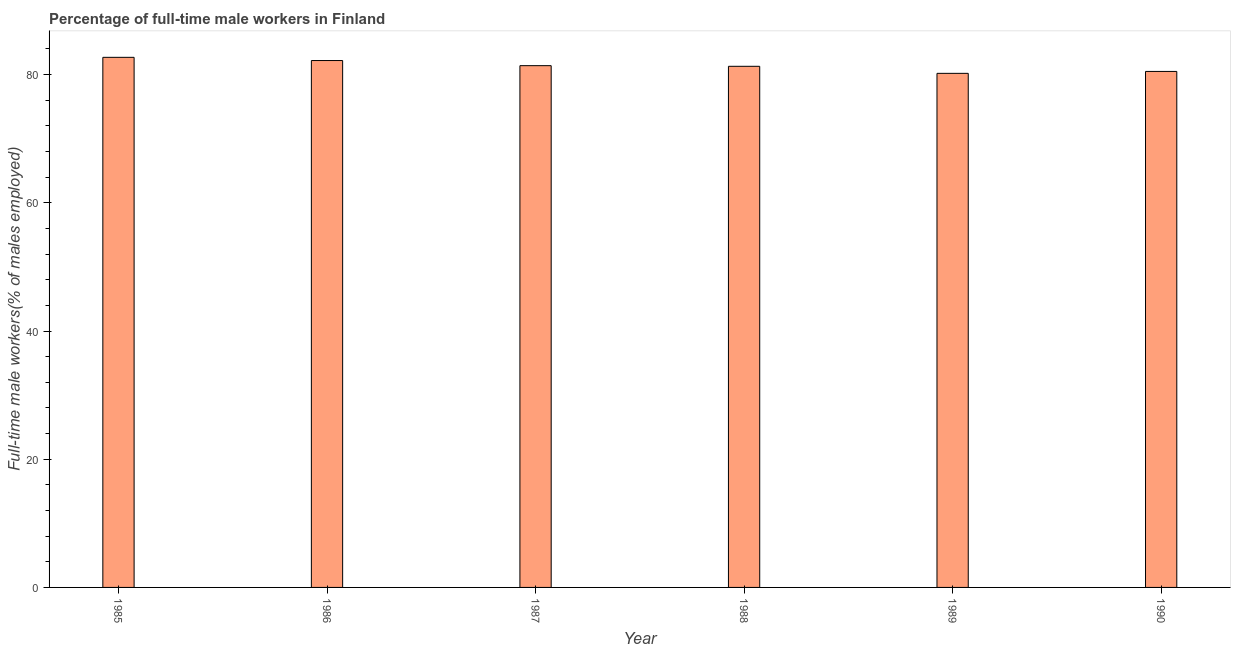Does the graph contain grids?
Your response must be concise. No. What is the title of the graph?
Provide a succinct answer. Percentage of full-time male workers in Finland. What is the label or title of the X-axis?
Make the answer very short. Year. What is the label or title of the Y-axis?
Offer a very short reply. Full-time male workers(% of males employed). What is the percentage of full-time male workers in 1987?
Your response must be concise. 81.4. Across all years, what is the maximum percentage of full-time male workers?
Offer a very short reply. 82.7. Across all years, what is the minimum percentage of full-time male workers?
Provide a short and direct response. 80.2. In which year was the percentage of full-time male workers maximum?
Give a very brief answer. 1985. What is the sum of the percentage of full-time male workers?
Keep it short and to the point. 488.3. What is the average percentage of full-time male workers per year?
Provide a short and direct response. 81.38. What is the median percentage of full-time male workers?
Your response must be concise. 81.35. What is the ratio of the percentage of full-time male workers in 1988 to that in 1990?
Provide a short and direct response. 1.01. Is the percentage of full-time male workers in 1986 less than that in 1989?
Provide a short and direct response. No. Is the difference between the percentage of full-time male workers in 1985 and 1986 greater than the difference between any two years?
Provide a short and direct response. No. What is the difference between the highest and the second highest percentage of full-time male workers?
Give a very brief answer. 0.5. Is the sum of the percentage of full-time male workers in 1986 and 1989 greater than the maximum percentage of full-time male workers across all years?
Your answer should be very brief. Yes. Are all the bars in the graph horizontal?
Provide a short and direct response. No. What is the difference between two consecutive major ticks on the Y-axis?
Your response must be concise. 20. What is the Full-time male workers(% of males employed) of 1985?
Provide a short and direct response. 82.7. What is the Full-time male workers(% of males employed) of 1986?
Give a very brief answer. 82.2. What is the Full-time male workers(% of males employed) of 1987?
Ensure brevity in your answer.  81.4. What is the Full-time male workers(% of males employed) in 1988?
Provide a short and direct response. 81.3. What is the Full-time male workers(% of males employed) in 1989?
Offer a very short reply. 80.2. What is the Full-time male workers(% of males employed) in 1990?
Ensure brevity in your answer.  80.5. What is the difference between the Full-time male workers(% of males employed) in 1985 and 1986?
Provide a short and direct response. 0.5. What is the difference between the Full-time male workers(% of males employed) in 1985 and 1988?
Keep it short and to the point. 1.4. What is the difference between the Full-time male workers(% of males employed) in 1985 and 1989?
Your answer should be very brief. 2.5. What is the difference between the Full-time male workers(% of males employed) in 1986 and 1988?
Keep it short and to the point. 0.9. What is the difference between the Full-time male workers(% of males employed) in 1986 and 1989?
Your answer should be compact. 2. What is the difference between the Full-time male workers(% of males employed) in 1987 and 1989?
Your answer should be very brief. 1.2. What is the difference between the Full-time male workers(% of males employed) in 1987 and 1990?
Give a very brief answer. 0.9. What is the difference between the Full-time male workers(% of males employed) in 1988 and 1989?
Give a very brief answer. 1.1. What is the difference between the Full-time male workers(% of males employed) in 1989 and 1990?
Your response must be concise. -0.3. What is the ratio of the Full-time male workers(% of males employed) in 1985 to that in 1986?
Give a very brief answer. 1.01. What is the ratio of the Full-time male workers(% of males employed) in 1985 to that in 1987?
Your answer should be very brief. 1.02. What is the ratio of the Full-time male workers(% of males employed) in 1985 to that in 1989?
Offer a terse response. 1.03. What is the ratio of the Full-time male workers(% of males employed) in 1986 to that in 1989?
Offer a terse response. 1.02. What is the ratio of the Full-time male workers(% of males employed) in 1986 to that in 1990?
Offer a terse response. 1.02. What is the ratio of the Full-time male workers(% of males employed) in 1987 to that in 1989?
Make the answer very short. 1.01. 